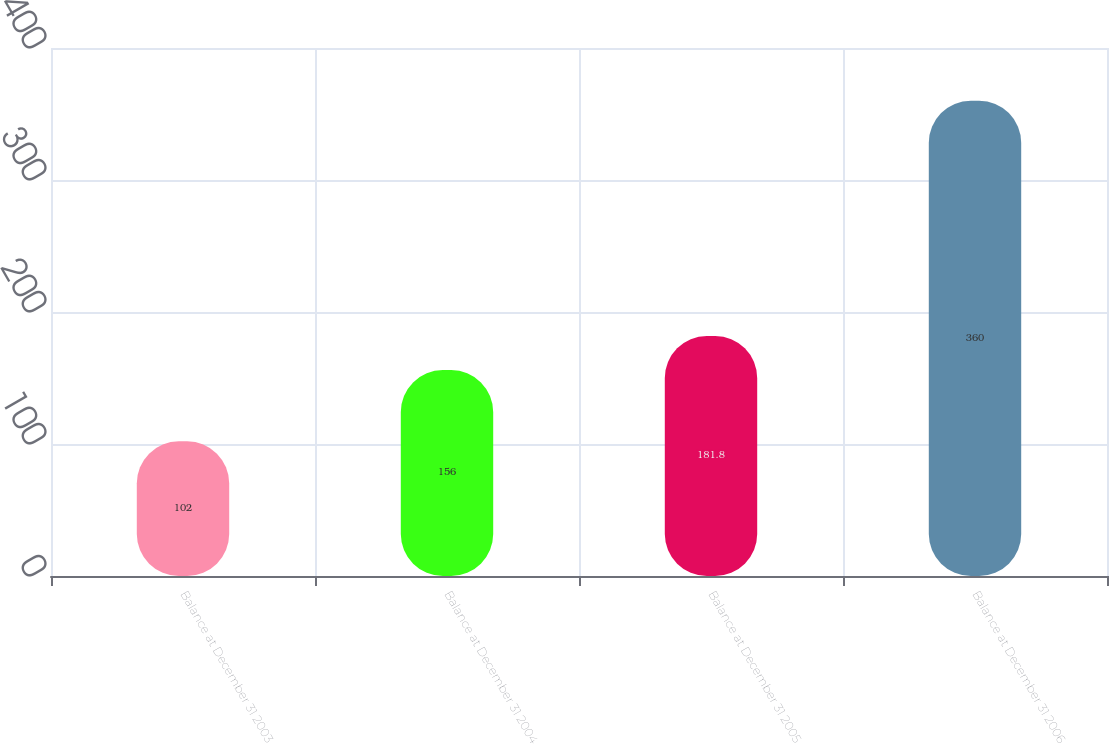<chart> <loc_0><loc_0><loc_500><loc_500><bar_chart><fcel>Balance at December 31 2003<fcel>Balance at December 31 2004<fcel>Balance at December 31 2005<fcel>Balance at December 31 2006<nl><fcel>102<fcel>156<fcel>181.8<fcel>360<nl></chart> 